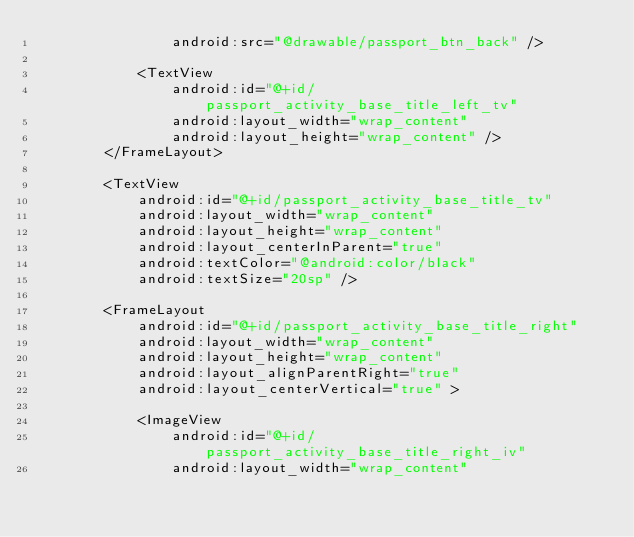Convert code to text. <code><loc_0><loc_0><loc_500><loc_500><_XML_>                android:src="@drawable/passport_btn_back" />

            <TextView
                android:id="@+id/passport_activity_base_title_left_tv"
                android:layout_width="wrap_content"
                android:layout_height="wrap_content" />
        </FrameLayout>

        <TextView
            android:id="@+id/passport_activity_base_title_tv"
            android:layout_width="wrap_content"
            android:layout_height="wrap_content"
            android:layout_centerInParent="true"
            android:textColor="@android:color/black"
            android:textSize="20sp" />

        <FrameLayout
            android:id="@+id/passport_activity_base_title_right"
            android:layout_width="wrap_content"
            android:layout_height="wrap_content"
            android:layout_alignParentRight="true"
            android:layout_centerVertical="true" >

            <ImageView
                android:id="@+id/passport_activity_base_title_right_iv"
                android:layout_width="wrap_content"</code> 